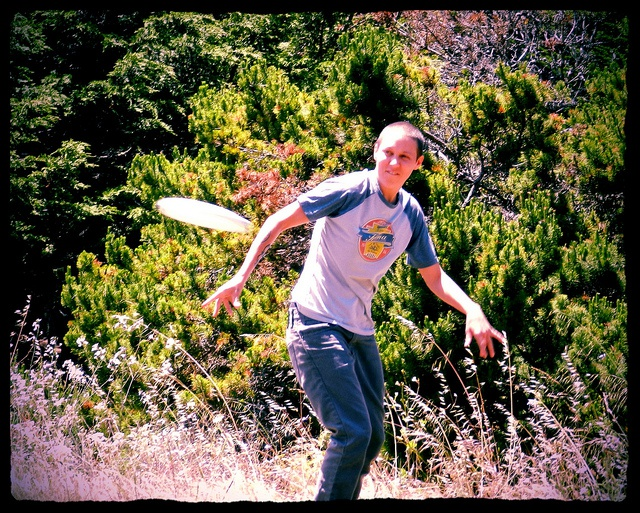Describe the objects in this image and their specific colors. I can see people in black, white, navy, and pink tones and frisbee in black, white, tan, and darkgray tones in this image. 